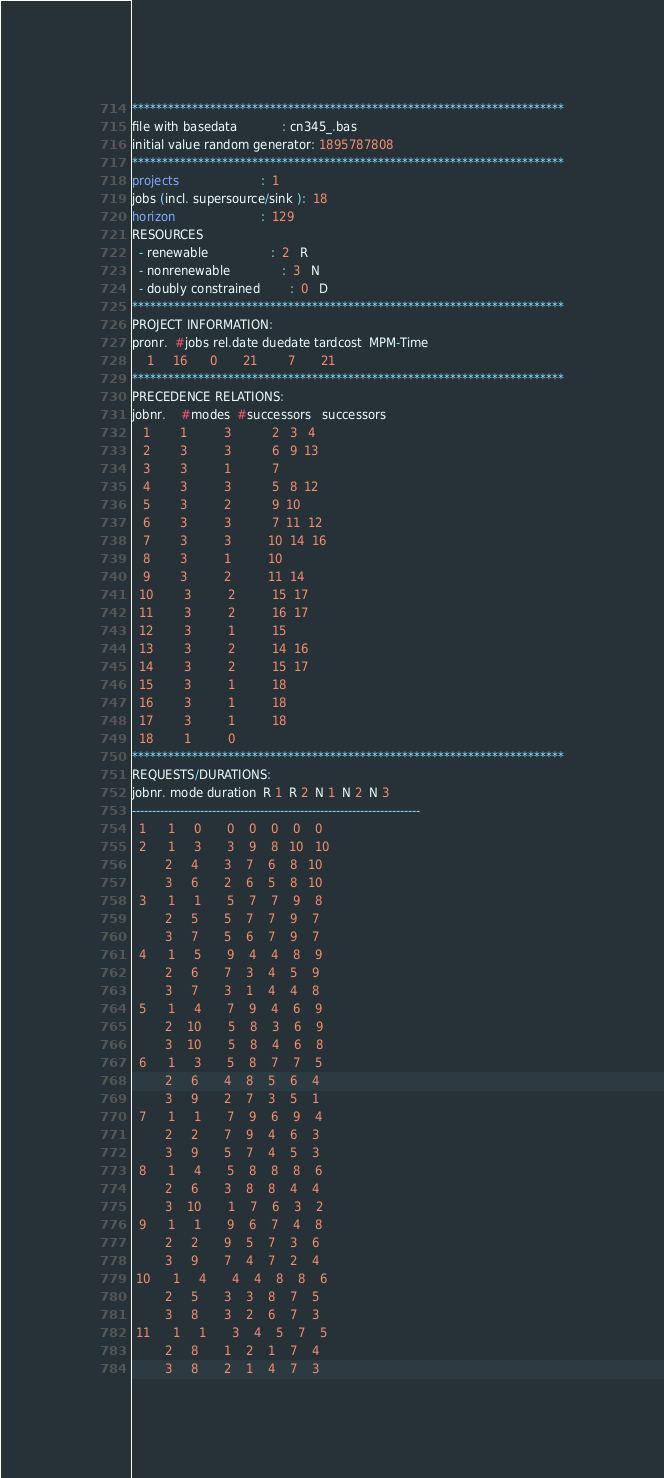Convert code to text. <code><loc_0><loc_0><loc_500><loc_500><_ObjectiveC_>************************************************************************
file with basedata            : cn345_.bas
initial value random generator: 1895787808
************************************************************************
projects                      :  1
jobs (incl. supersource/sink ):  18
horizon                       :  129
RESOURCES
  - renewable                 :  2   R
  - nonrenewable              :  3   N
  - doubly constrained        :  0   D
************************************************************************
PROJECT INFORMATION:
pronr.  #jobs rel.date duedate tardcost  MPM-Time
    1     16      0       21        7       21
************************************************************************
PRECEDENCE RELATIONS:
jobnr.    #modes  #successors   successors
   1        1          3           2   3   4
   2        3          3           6   9  13
   3        3          1           7
   4        3          3           5   8  12
   5        3          2           9  10
   6        3          3           7  11  12
   7        3          3          10  14  16
   8        3          1          10
   9        3          2          11  14
  10        3          2          15  17
  11        3          2          16  17
  12        3          1          15
  13        3          2          14  16
  14        3          2          15  17
  15        3          1          18
  16        3          1          18
  17        3          1          18
  18        1          0        
************************************************************************
REQUESTS/DURATIONS:
jobnr. mode duration  R 1  R 2  N 1  N 2  N 3
------------------------------------------------------------------------
  1      1     0       0    0    0    0    0
  2      1     3       3    9    8   10   10
         2     4       3    7    6    8   10
         3     6       2    6    5    8   10
  3      1     1       5    7    7    9    8
         2     5       5    7    7    9    7
         3     7       5    6    7    9    7
  4      1     5       9    4    4    8    9
         2     6       7    3    4    5    9
         3     7       3    1    4    4    8
  5      1     4       7    9    4    6    9
         2    10       5    8    3    6    9
         3    10       5    8    4    6    8
  6      1     3       5    8    7    7    5
         2     6       4    8    5    6    4
         3     9       2    7    3    5    1
  7      1     1       7    9    6    9    4
         2     2       7    9    4    6    3
         3     9       5    7    4    5    3
  8      1     4       5    8    8    8    6
         2     6       3    8    8    4    4
         3    10       1    7    6    3    2
  9      1     1       9    6    7    4    8
         2     2       9    5    7    3    6
         3     9       7    4    7    2    4
 10      1     4       4    4    8    8    6
         2     5       3    3    8    7    5
         3     8       3    2    6    7    3
 11      1     1       3    4    5    7    5
         2     8       1    2    1    7    4
         3     8       2    1    4    7    3</code> 